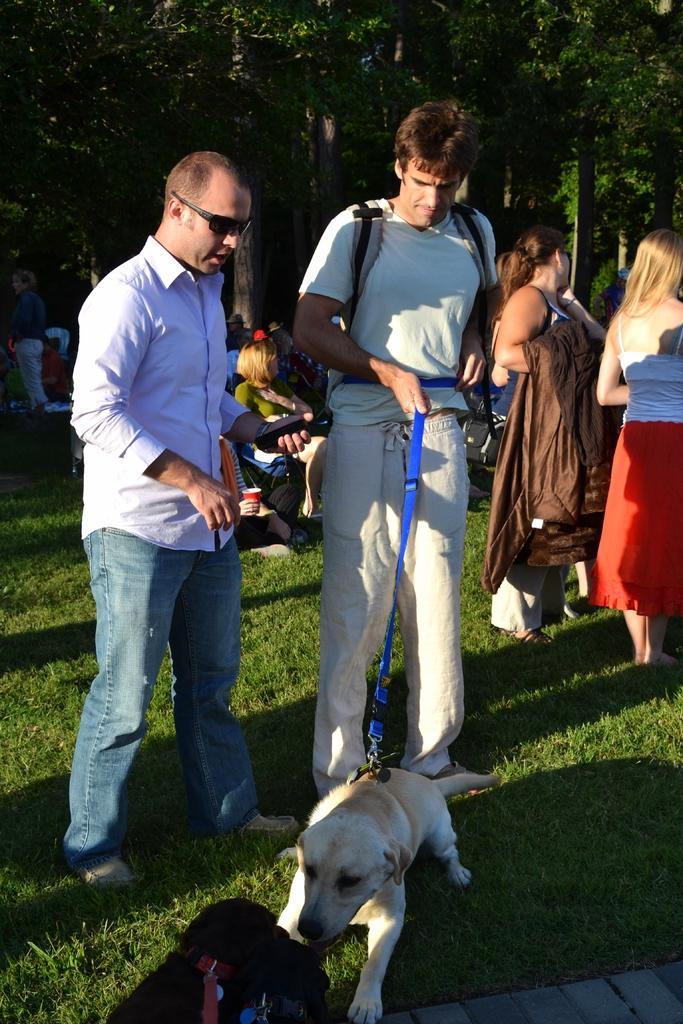Can you describe this image briefly? this picture shows few people standing and few are seated and we see a man Standing and holding a dog with the help of a string and we see a other man watching it and we see trees back of them 